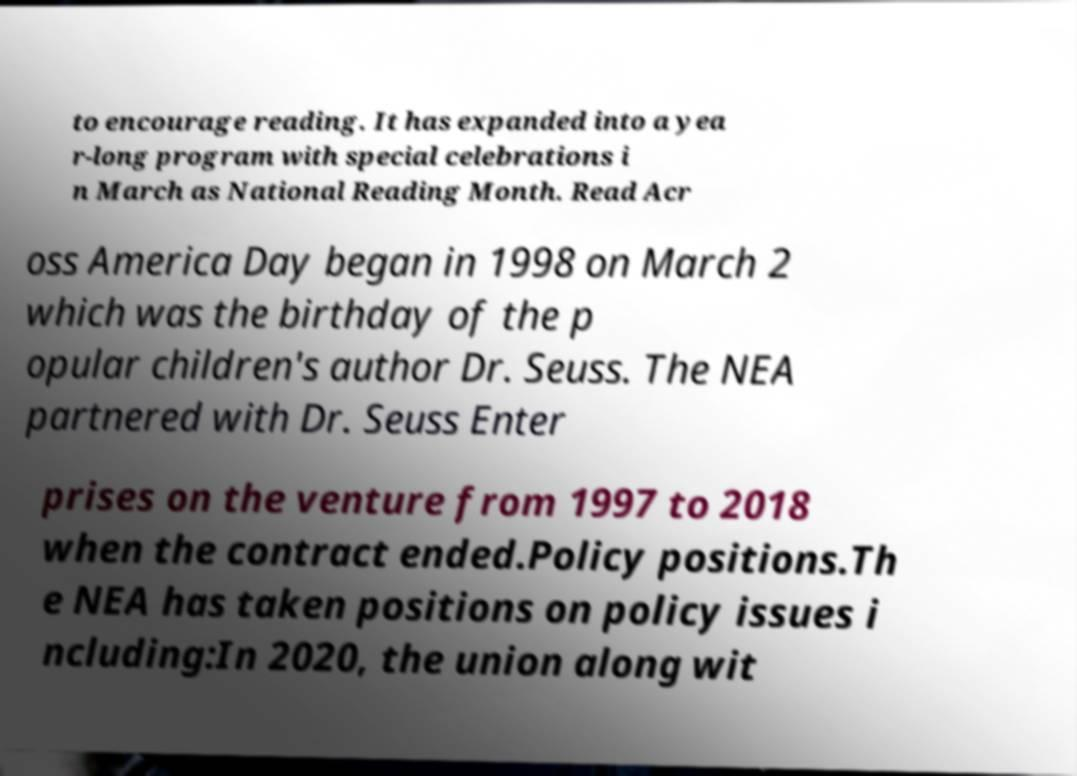Please read and relay the text visible in this image. What does it say? to encourage reading. It has expanded into a yea r-long program with special celebrations i n March as National Reading Month. Read Acr oss America Day began in 1998 on March 2 which was the birthday of the p opular children's author Dr. Seuss. The NEA partnered with Dr. Seuss Enter prises on the venture from 1997 to 2018 when the contract ended.Policy positions.Th e NEA has taken positions on policy issues i ncluding:In 2020, the union along wit 